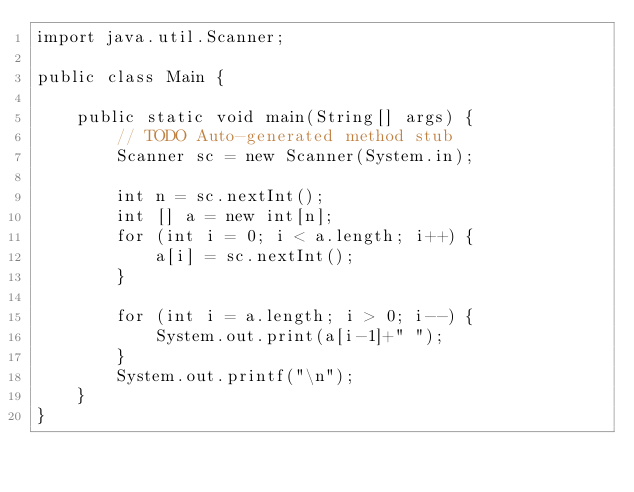<code> <loc_0><loc_0><loc_500><loc_500><_Java_>import java.util.Scanner;

public class Main {
	
	public static void main(String[] args) {
		// TODO Auto-generated method stub
		Scanner sc = new Scanner(System.in);
		
		int n = sc.nextInt();
		int [] a = new int[n];
		for (int i = 0; i < a.length; i++) {
			a[i] = sc.nextInt();
		}
		
		for (int i = a.length; i > 0; i--) {
			System.out.print(a[i-1]+" ");
		}
		System.out.printf("\n");
	}
}

</code> 